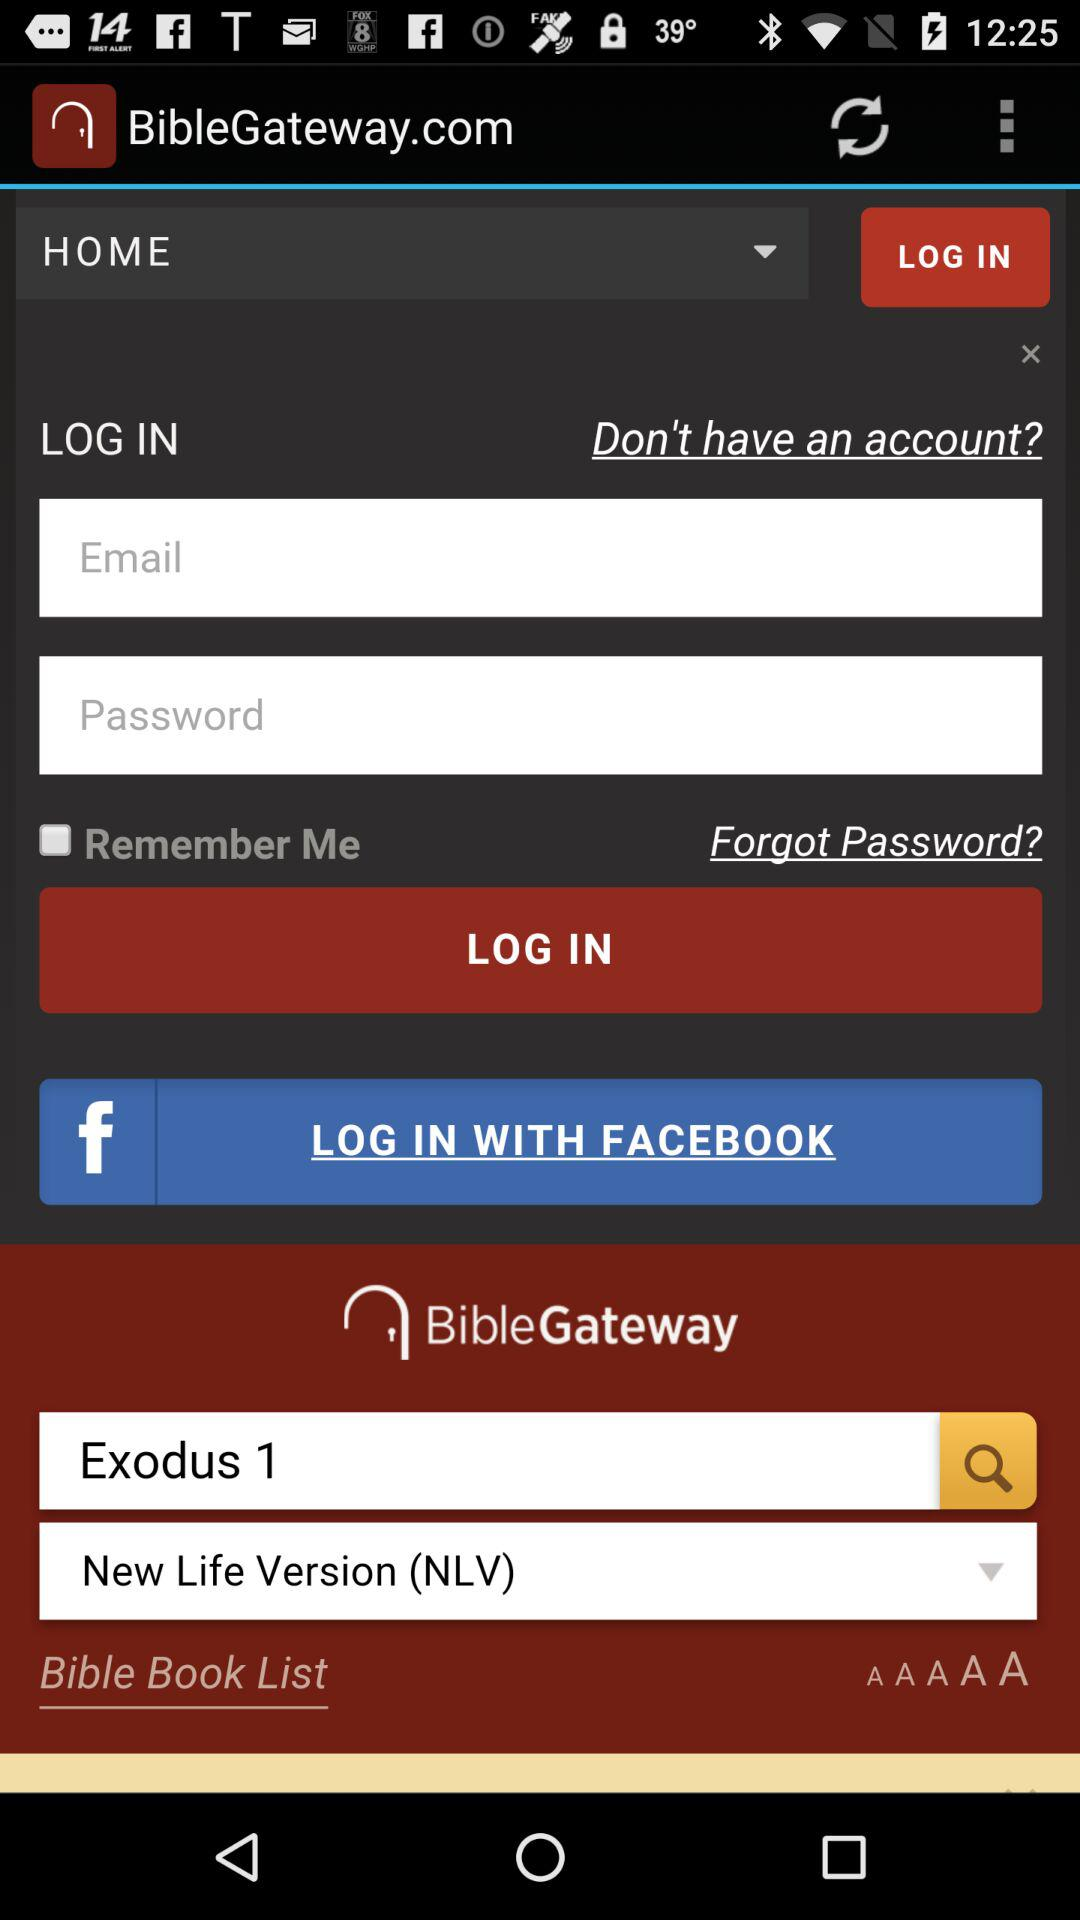What is the status of "Remember Me"? The status of "Remember Me" is "off". 